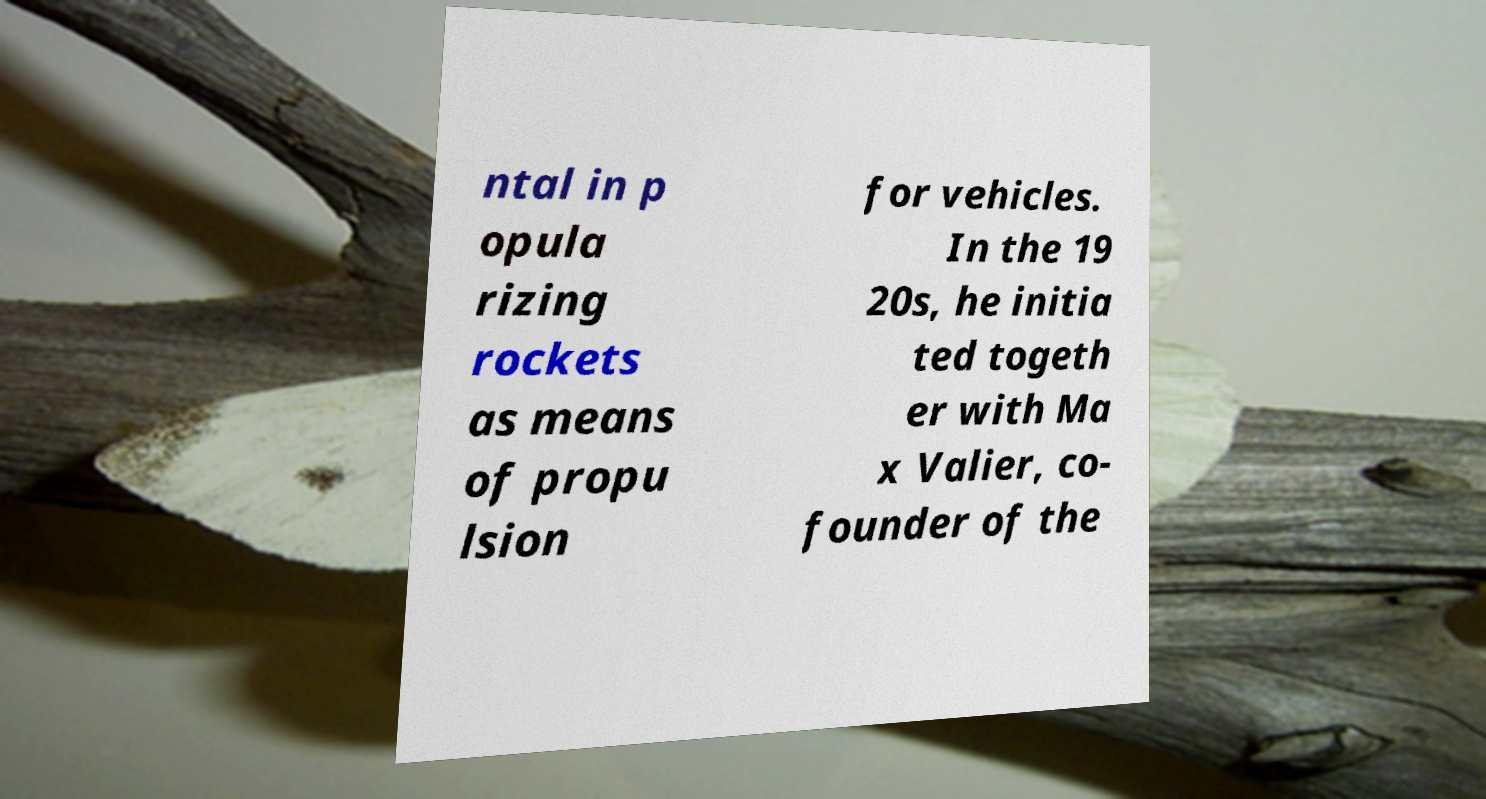Can you accurately transcribe the text from the provided image for me? ntal in p opula rizing rockets as means of propu lsion for vehicles. In the 19 20s, he initia ted togeth er with Ma x Valier, co- founder of the 